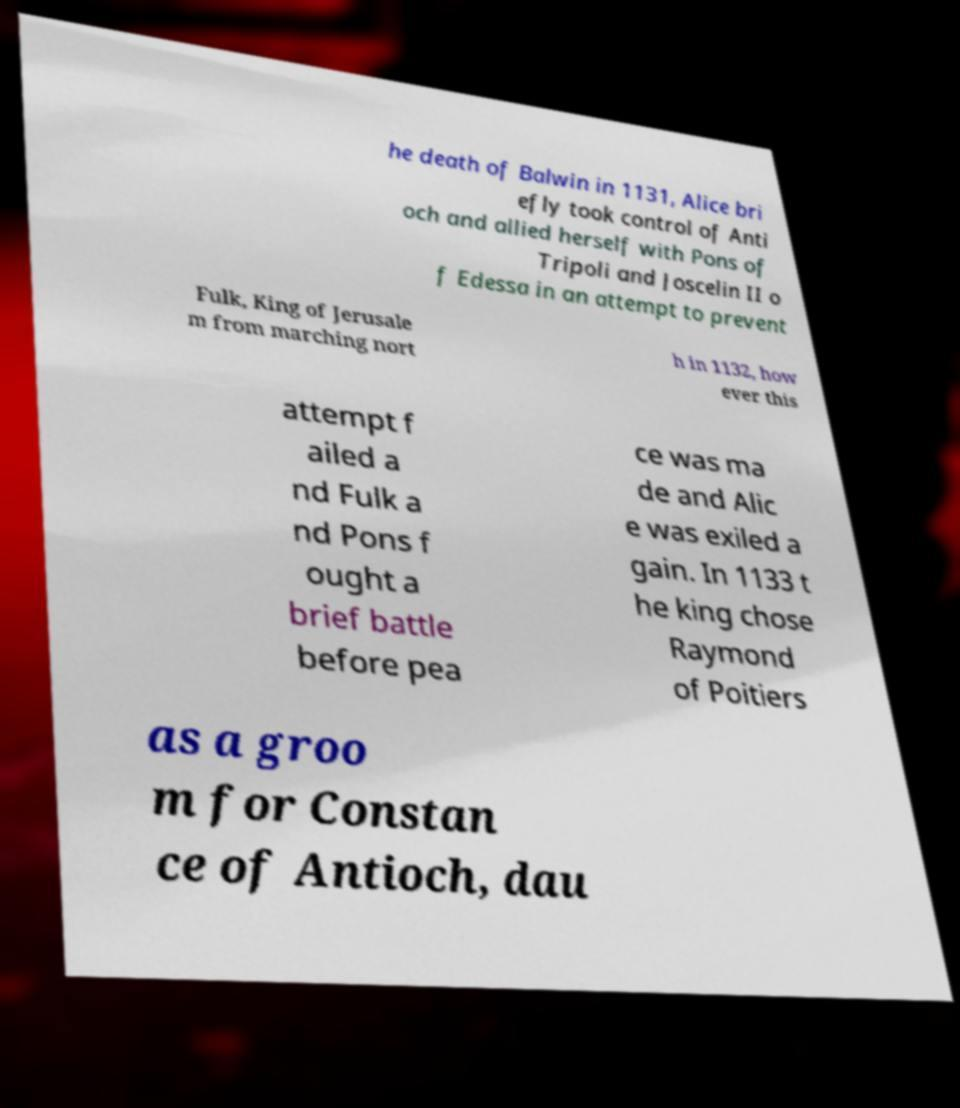There's text embedded in this image that I need extracted. Can you transcribe it verbatim? he death of Balwin in 1131, Alice bri efly took control of Anti och and allied herself with Pons of Tripoli and Joscelin II o f Edessa in an attempt to prevent Fulk, King of Jerusale m from marching nort h in 1132, how ever this attempt f ailed a nd Fulk a nd Pons f ought a brief battle before pea ce was ma de and Alic e was exiled a gain. In 1133 t he king chose Raymond of Poitiers as a groo m for Constan ce of Antioch, dau 